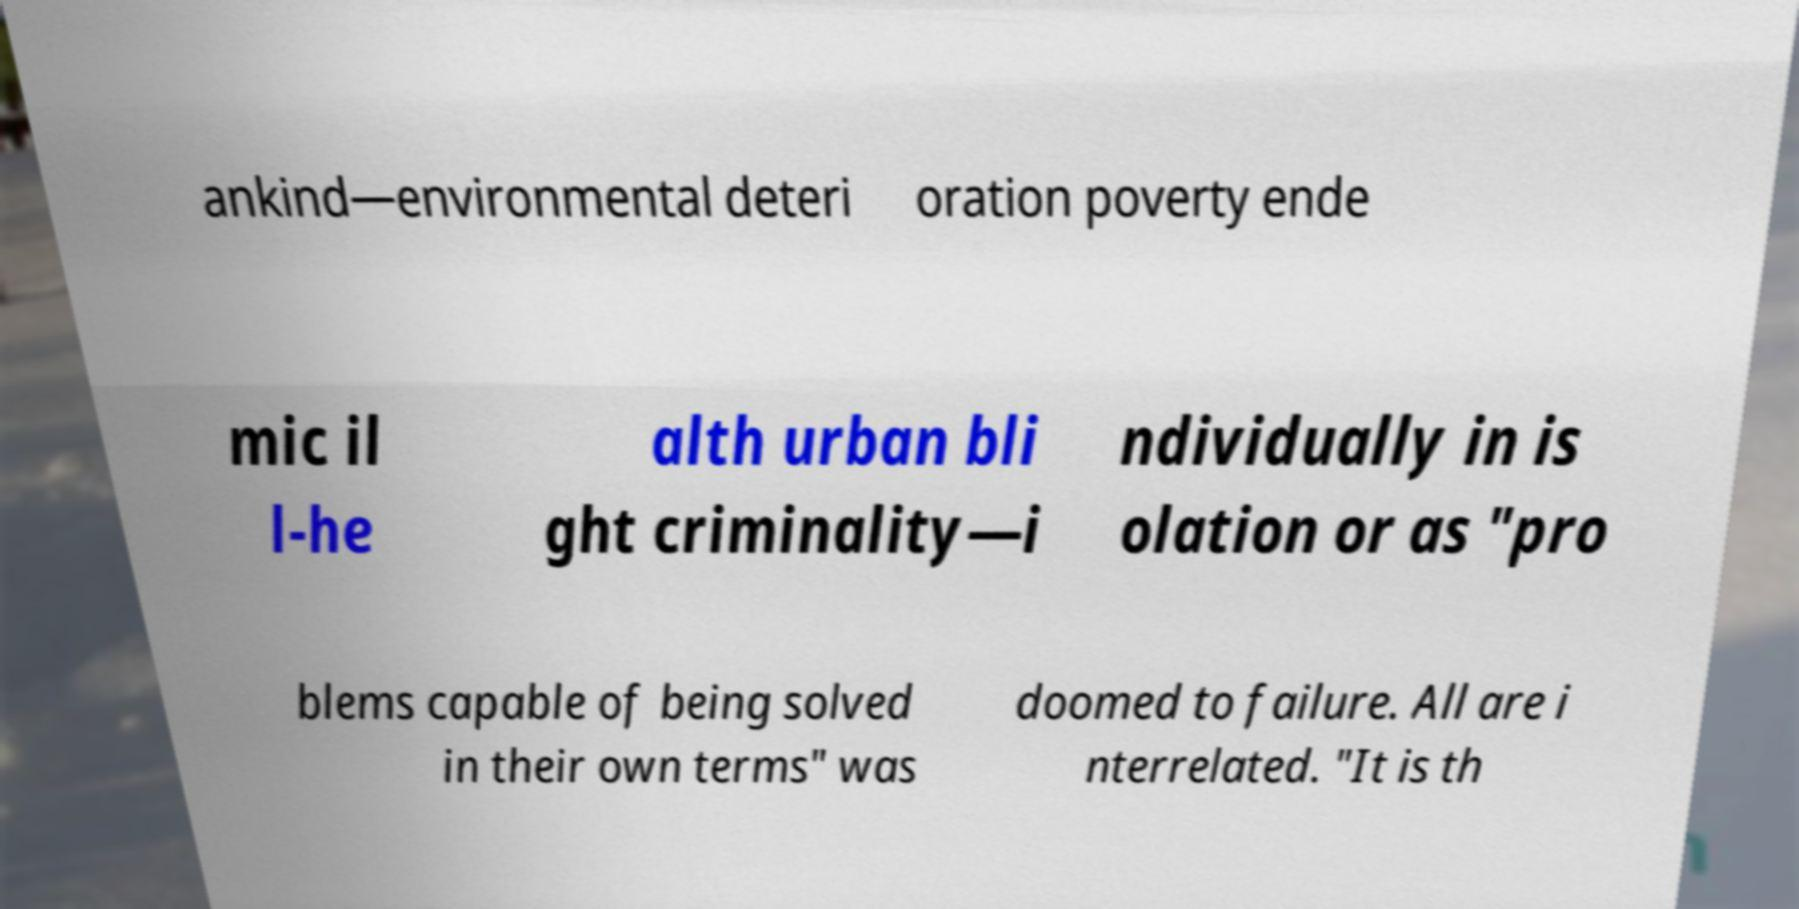There's text embedded in this image that I need extracted. Can you transcribe it verbatim? ankind—environmental deteri oration poverty ende mic il l-he alth urban bli ght criminality—i ndividually in is olation or as "pro blems capable of being solved in their own terms" was doomed to failure. All are i nterrelated. "It is th 